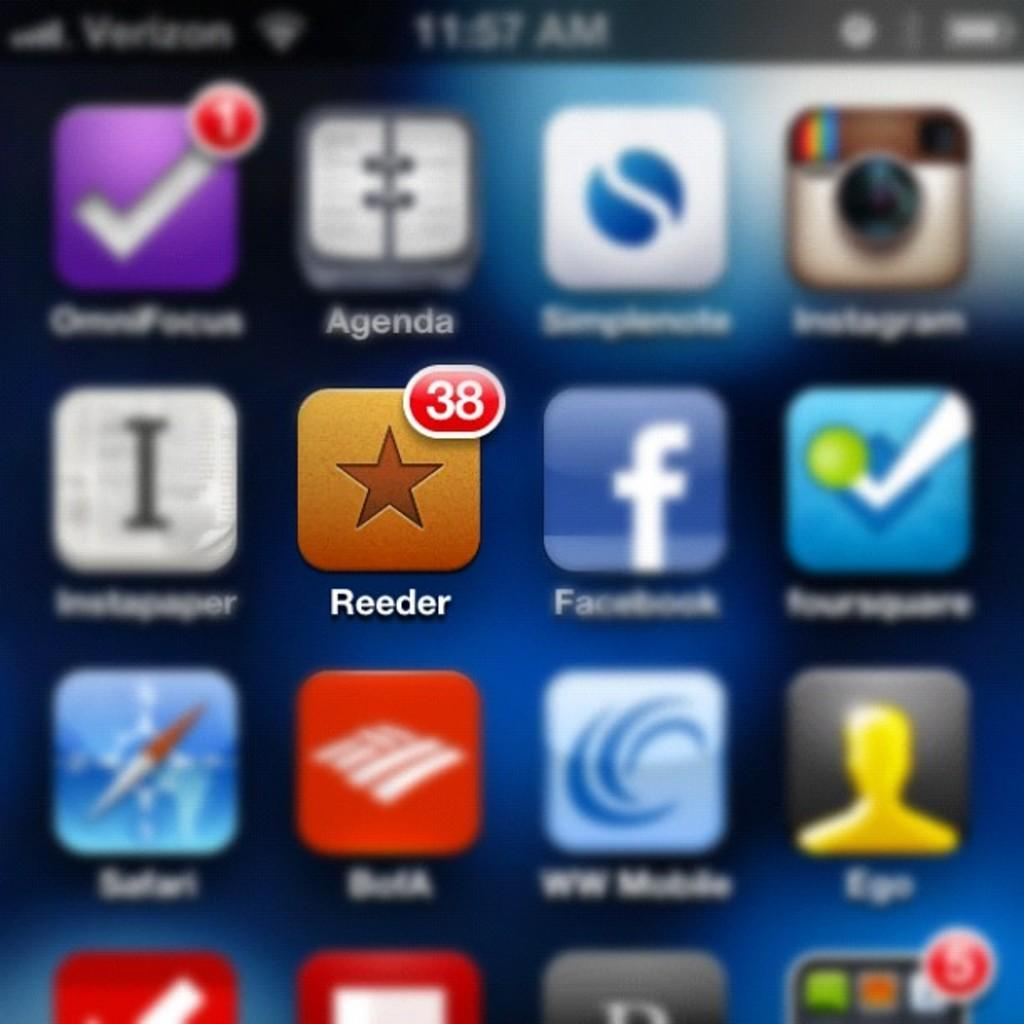<image>
Relay a brief, clear account of the picture shown. A screen shot of a phone with the app Reeder emphasized. 